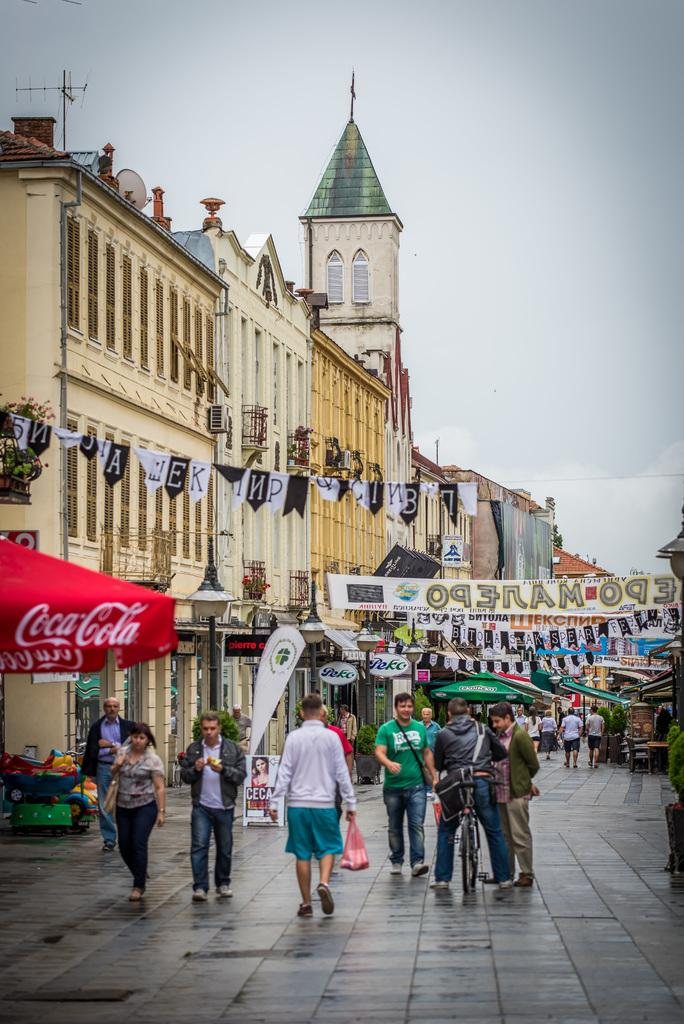Who or what can be seen in the image? There are people in the image. What structures are located on the left side of the image? There are buildings on the left side of the image. What can be seen in the sky in the background of the image? There are clouds visible in the sky in the background of the image. What type of bushes can be seen in the image? There are no bushes present in the image. 